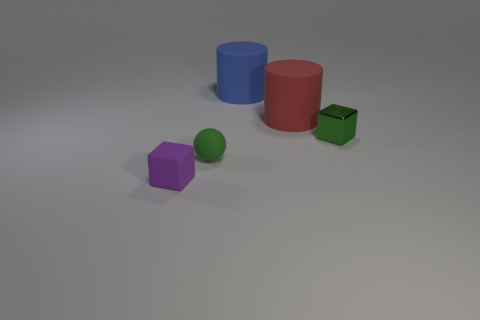Are there fewer blue matte cylinders that are in front of the large blue rubber cylinder than tiny matte blocks behind the small purple matte cube?
Your response must be concise. No. What number of red objects are metal cubes or small rubber cubes?
Give a very brief answer. 0. Are there an equal number of green rubber objects left of the small purple rubber thing and cyan metal blocks?
Your answer should be very brief. Yes. How many objects are either small green blocks or rubber things that are to the right of the tiny purple rubber object?
Give a very brief answer. 4. Do the tiny ball and the small rubber cube have the same color?
Your answer should be compact. No. Are there any tiny red things made of the same material as the big red cylinder?
Provide a short and direct response. No. What is the color of the other matte object that is the same shape as the blue rubber object?
Your response must be concise. Red. Are the small purple block and the block that is behind the small rubber ball made of the same material?
Ensure brevity in your answer.  No. What is the shape of the tiny matte object that is to the right of the tiny block that is in front of the sphere?
Provide a succinct answer. Sphere. There is a cube behind the green sphere; is it the same size as the purple block?
Provide a short and direct response. Yes. 